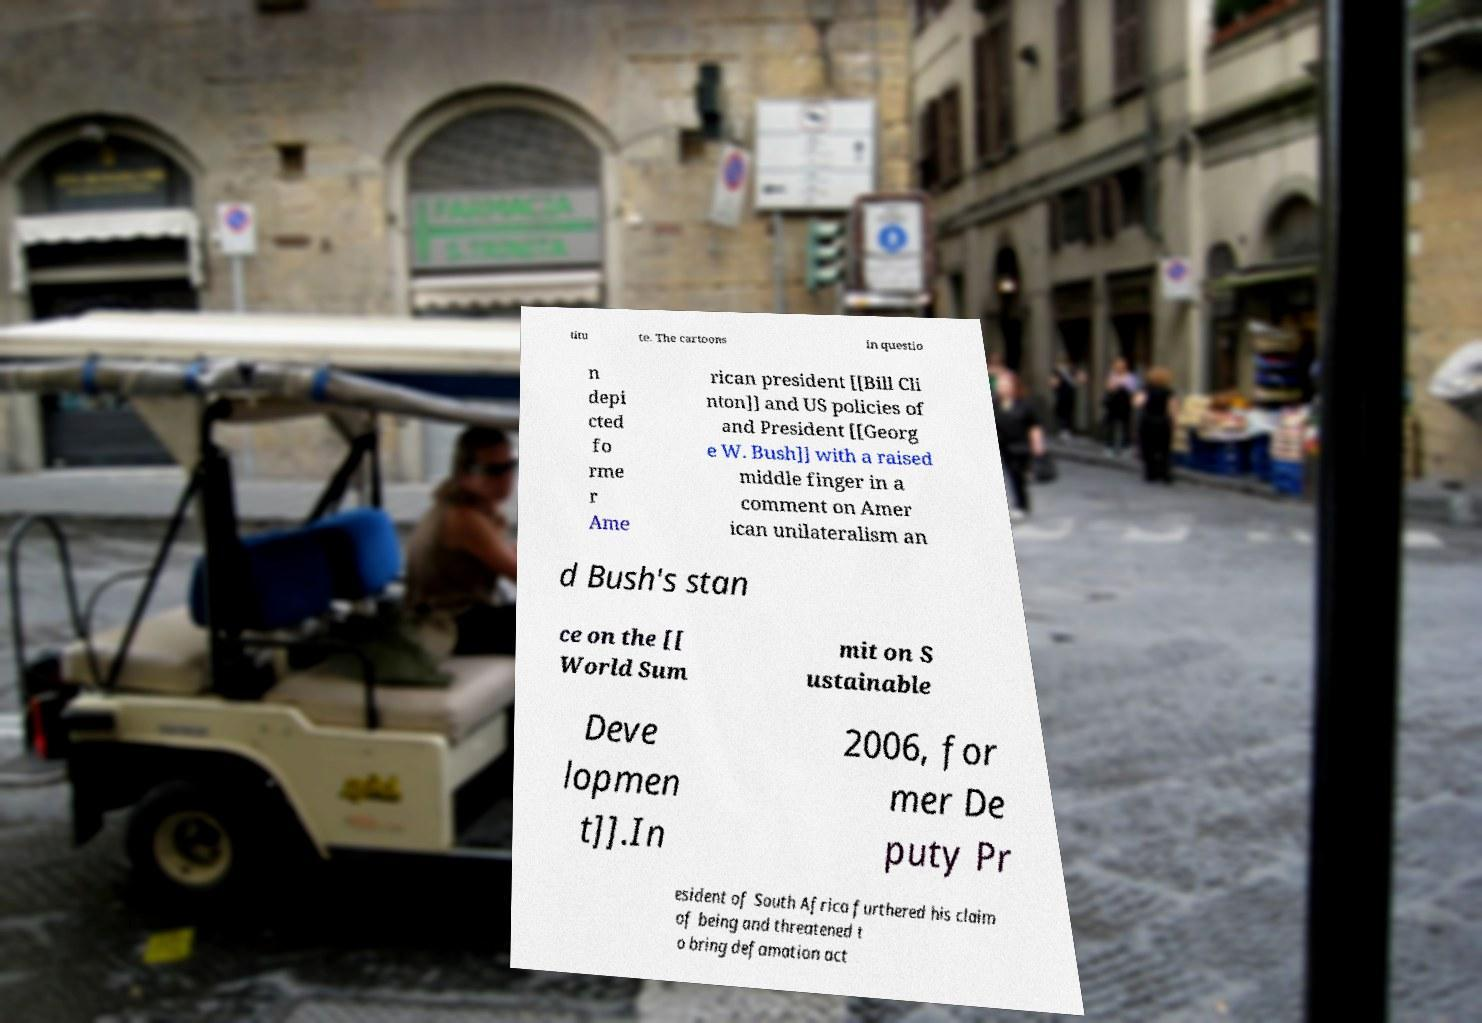Please identify and transcribe the text found in this image. titu te. The cartoons in questio n depi cted fo rme r Ame rican president [[Bill Cli nton]] and US policies of and President [[Georg e W. Bush]] with a raised middle finger in a comment on Amer ican unilateralism an d Bush's stan ce on the [[ World Sum mit on S ustainable Deve lopmen t]].In 2006, for mer De puty Pr esident of South Africa furthered his claim of being and threatened t o bring defamation act 